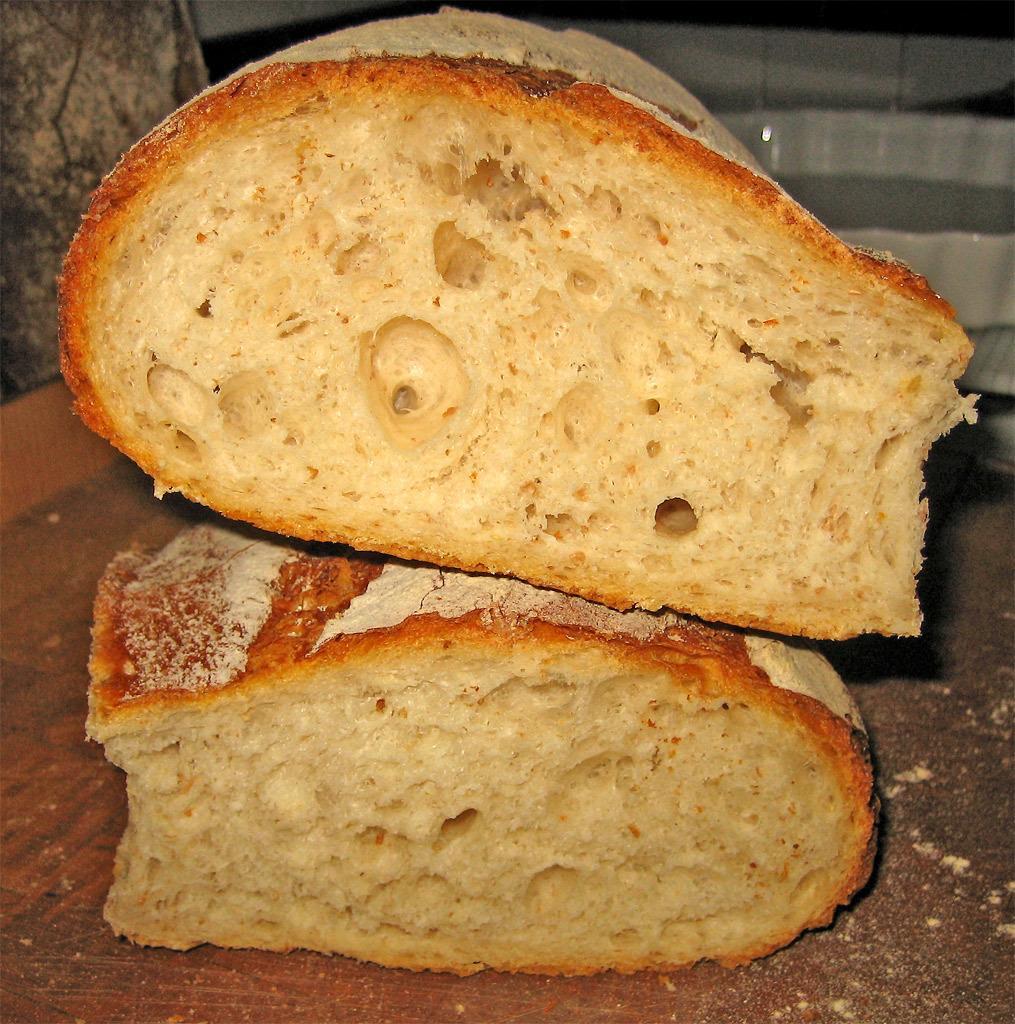Describe this image in one or two sentences. In the picture we can see a wooden plank on it, we can see two bun slices one on the other and behind it we can see the white color bowl. 